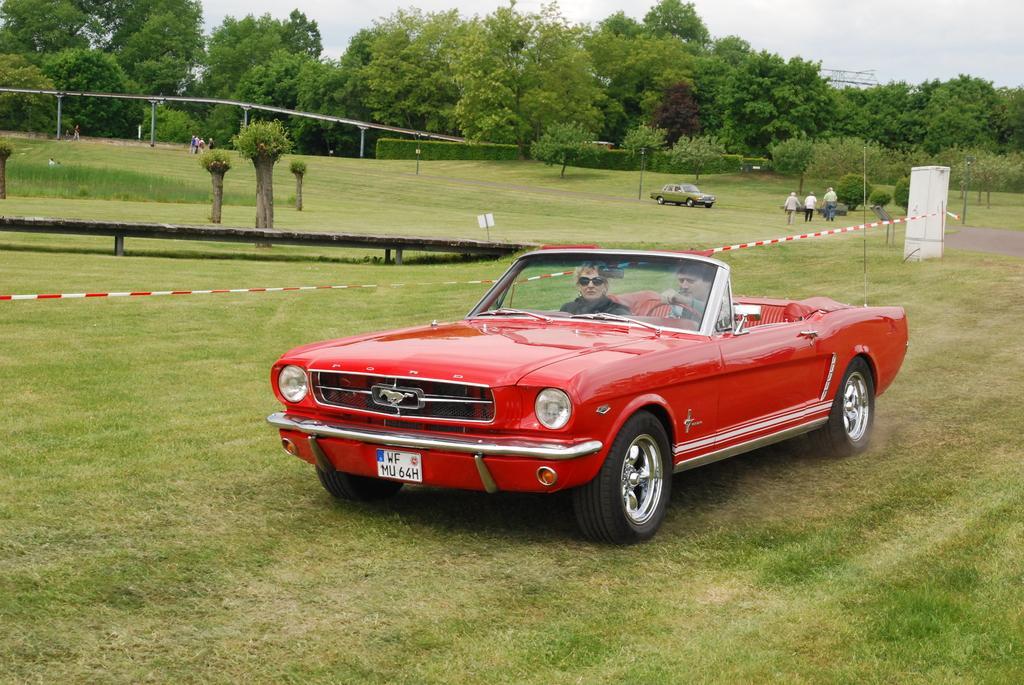Describe this image in one or two sentences. In the foreground of this image, there are two persons inside a red car moving on the grass. In the background, there is a wooden object on the right, a ribbon, two bridges, trees, persons walking on the grass, a vehicle moving on the road, sky and the cloud on the top. 